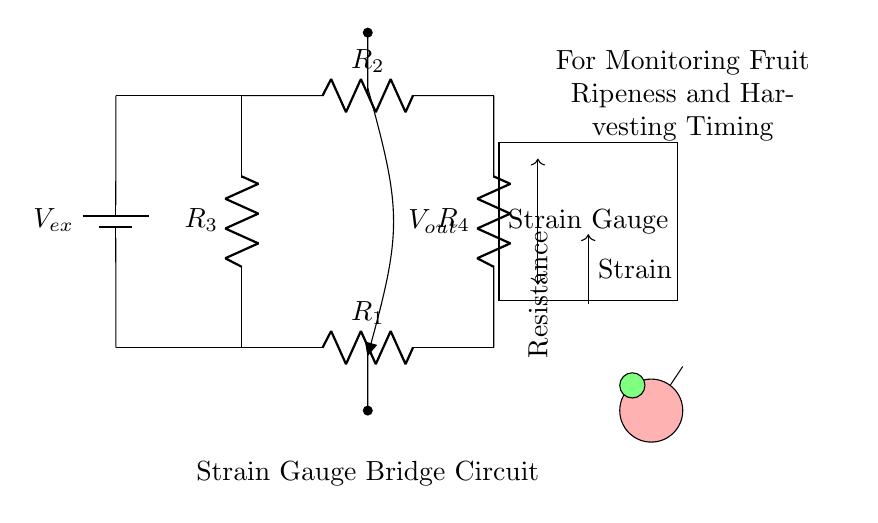What type of circuit is this? This circuit is a Wheatstone bridge circuit, which is used for measuring unknown resistances and is specifically tailored for applications like strain measurement through strain gauges.
Answer: Wheatstone bridge What is the role of the strain gauge in this circuit? The strain gauge acts as one of the resistive elements in the bridge; it changes resistance in response to mechanical deformation, which is essential for monitoring ripeness by measuring strain in fruit.
Answer: Monitor strain What is the power source used in this circuit? The power source is a battery which provides the excitation voltage to the circuit. It supplies energy that drives current through the resistors and strain gauge.
Answer: Battery What does the output voltage indicate? The output voltage represents the differential voltage across the bridge, which changes when the strain gauge's resistance varies with the ripeness of the fruit, thus helping to determine optimal harvesting time.
Answer: Differential voltage Which components form the upper branch of the bridge? The upper branch is formed by resistors R2 and R4, which are connected in series, allowing for a balanced condition in the bridge when R3 is set against them.
Answer: R2 and R4 How is the output voltage connected in this circuit? The output voltage is taken between the two midpoints of the upper and lower branches of the bridge, where the voltage difference is measured to assess any imbalance caused by strain gauge resistance changes.
Answer: Between midpoints What does the resistance label indicate in the context of ripeness monitoring? The resistance label indicates that the strain gauge's resistance changes with the ripeness level of the fruit, allowing the circuit to detect subtle variations in strain as the produce matures.
Answer: Changes with ripeness 